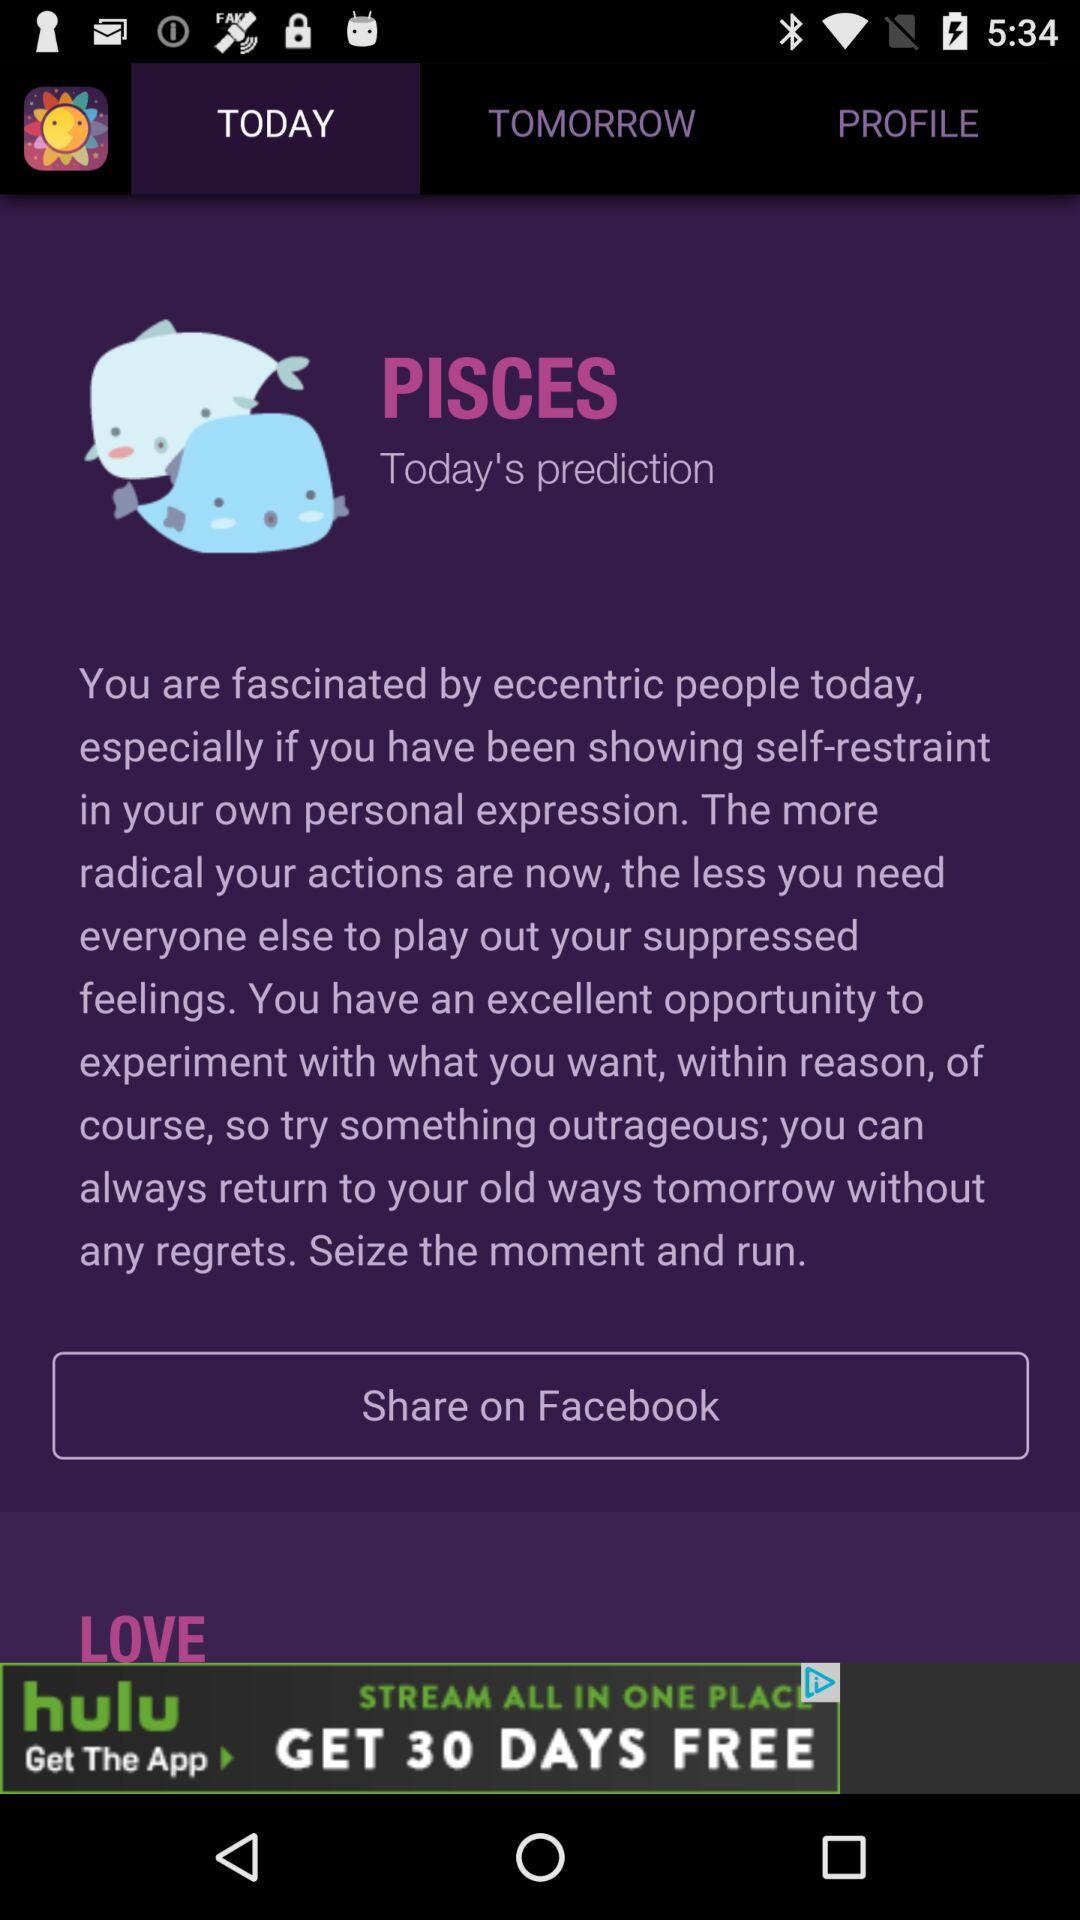What is the application name? The application name is "Horoscope". 